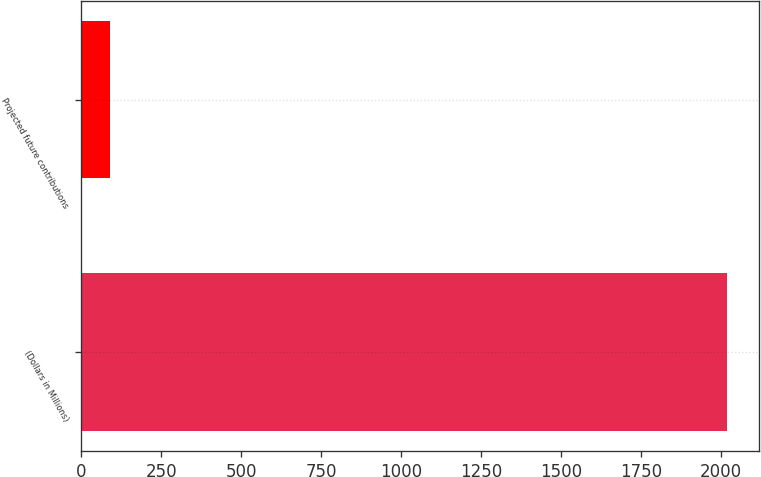Convert chart. <chart><loc_0><loc_0><loc_500><loc_500><bar_chart><fcel>(Dollars in Millions)<fcel>Projected future contributions<nl><fcel>2018<fcel>88<nl></chart> 